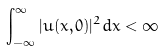Convert formula to latex. <formula><loc_0><loc_0><loc_500><loc_500>\int _ { - \infty } ^ { \infty } | u ( x , 0 ) | ^ { 2 } d x < \infty</formula> 